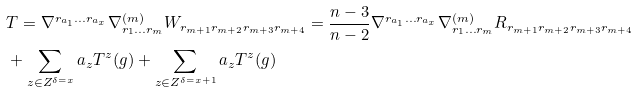Convert formula to latex. <formula><loc_0><loc_0><loc_500><loc_500>& T = \nabla ^ { r _ { a _ { 1 } } \dots r _ { a _ { x } } } \nabla ^ { ( m ) } _ { r _ { 1 } \dots r _ { m } } W _ { r _ { m + 1 } r _ { m + 2 } r _ { m + 3 } r _ { m + 4 } } = \frac { n - 3 } { n - 2 } \nabla ^ { r _ { a _ { 1 } } \dots r _ { a _ { x } } } \nabla ^ { ( m ) } _ { r _ { 1 } \dots r _ { m } } R _ { r _ { m + 1 } r _ { m + 2 } r _ { m + 3 } r _ { m + 4 } } \\ & + \sum _ { z \in Z ^ { \delta = x } } a _ { z } T ^ { z } ( g ) + \sum _ { z \in Z ^ { \delta = x + 1 } } a _ { z } T ^ { z } ( g )</formula> 